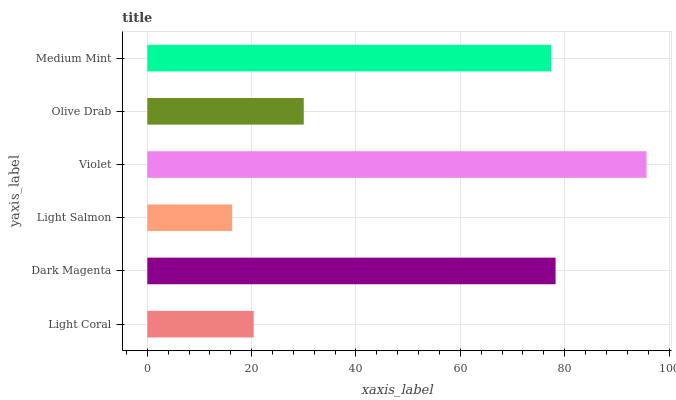Is Light Salmon the minimum?
Answer yes or no. Yes. Is Violet the maximum?
Answer yes or no. Yes. Is Dark Magenta the minimum?
Answer yes or no. No. Is Dark Magenta the maximum?
Answer yes or no. No. Is Dark Magenta greater than Light Coral?
Answer yes or no. Yes. Is Light Coral less than Dark Magenta?
Answer yes or no. Yes. Is Light Coral greater than Dark Magenta?
Answer yes or no. No. Is Dark Magenta less than Light Coral?
Answer yes or no. No. Is Medium Mint the high median?
Answer yes or no. Yes. Is Olive Drab the low median?
Answer yes or no. Yes. Is Violet the high median?
Answer yes or no. No. Is Dark Magenta the low median?
Answer yes or no. No. 